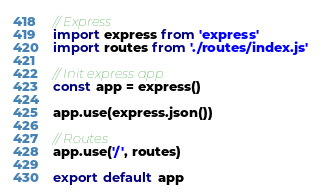Convert code to text. <code><loc_0><loc_0><loc_500><loc_500><_JavaScript_>// Express
import express from 'express'
import routes from './routes/index.js'

// Init express app
const app = express()

app.use(express.json())

// Routes
app.use('/', routes)

export default app
</code> 